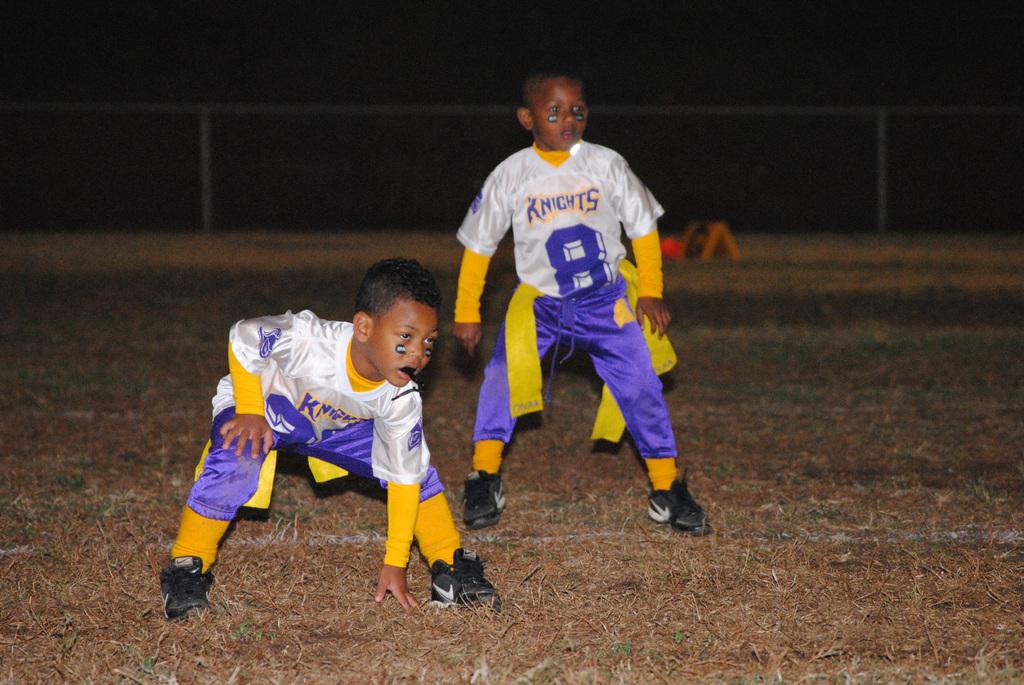Do these kids play for the knights team?
Offer a very short reply. Yes. What number is on the jersey on the right?
Provide a short and direct response. 8. 